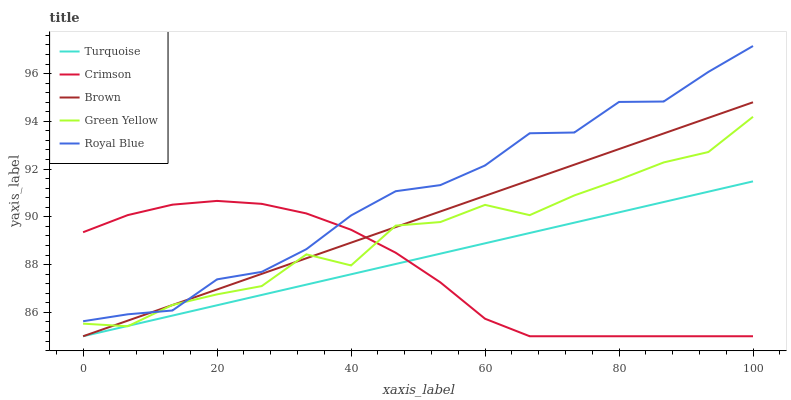Does Crimson have the minimum area under the curve?
Answer yes or no. Yes. Does Royal Blue have the maximum area under the curve?
Answer yes or no. Yes. Does Brown have the minimum area under the curve?
Answer yes or no. No. Does Brown have the maximum area under the curve?
Answer yes or no. No. Is Turquoise the smoothest?
Answer yes or no. Yes. Is Green Yellow the roughest?
Answer yes or no. Yes. Is Brown the smoothest?
Answer yes or no. No. Is Brown the roughest?
Answer yes or no. No. Does Crimson have the lowest value?
Answer yes or no. Yes. Does Green Yellow have the lowest value?
Answer yes or no. No. Does Royal Blue have the highest value?
Answer yes or no. Yes. Does Brown have the highest value?
Answer yes or no. No. Is Turquoise less than Royal Blue?
Answer yes or no. Yes. Is Royal Blue greater than Turquoise?
Answer yes or no. Yes. Does Crimson intersect Brown?
Answer yes or no. Yes. Is Crimson less than Brown?
Answer yes or no. No. Is Crimson greater than Brown?
Answer yes or no. No. Does Turquoise intersect Royal Blue?
Answer yes or no. No. 